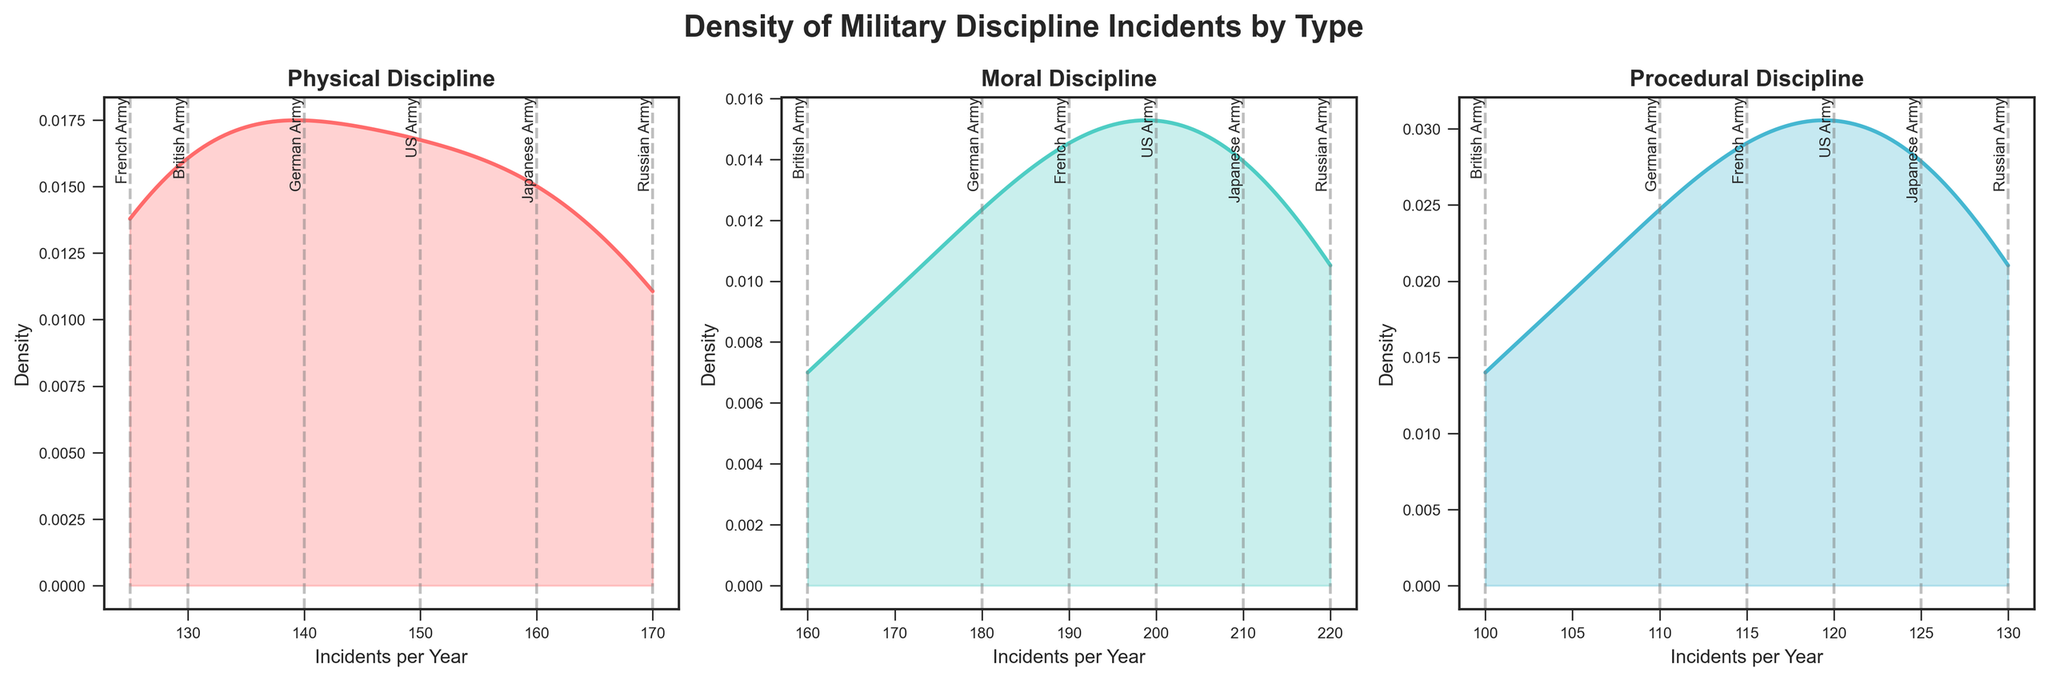Which discipline type has the highest peak density? By observing the plots, identify which density curve reaches the highest point on the y-axis.
Answer: Moral Discipline Which army has the lowest number of procedural discipline incidents? The plot for procedural discipline shows vertical lines representing each army's incidents. Look for the lowest line in the procedural subplot.
Answer: British Army Are physical discipline incidents more frequent in the Russian Army than in the US Army? In the physical discipline subplot, compare the vertical lines corresponding to the Russian and US Armies. The Russian Army's line is positioned further right.
Answer: Yes Which discipline type shows the most variability in incident density? Observe the width and spread of the density curves in each subplot. The wider and less peaked the curve, the higher the variability.
Answer: Moral Discipline How do the incidents of moral discipline in the German Army compare to the French Army? Compare the positions of the vertical lines in the moral discipline subplot for both German and French Armies. The German Army's line is positioned left of the French Army's, indicating fewer incidents.
Answer: Lower What is the approximate density value at 150 incidents per year for physical discipline? Locate the 150 mark on the x-axis in the physical discipline subplot and find the height of the density curve at this point.
Answer: Approximately 0.014 Is there a clear outlier in the number of moral discipline incidents among the armies? Examine the vertical line placements in the moral discipline subplot to see if any line is significantly apart from others. The Russian Army's line is noticeably furthest right.
Answer: Yes Which two armies have the closest number of physical discipline incidents? Look at the vertical lines in the physical discipline subplot and find two lines that are very close together. The US and German Armies have their lines close to each other.
Answer: US Army and German Army What can be inferred about the procedural discipline incidents in the Japanese Army compared to the US Army? Look at the vertical lines in the procedural discipline subplot for the Japanese and US Armies. The line for the Japanese Army is positioned slightly left of the US Army's line, indicating fewer incidents.
Answer: Fewer in Japanese Army 